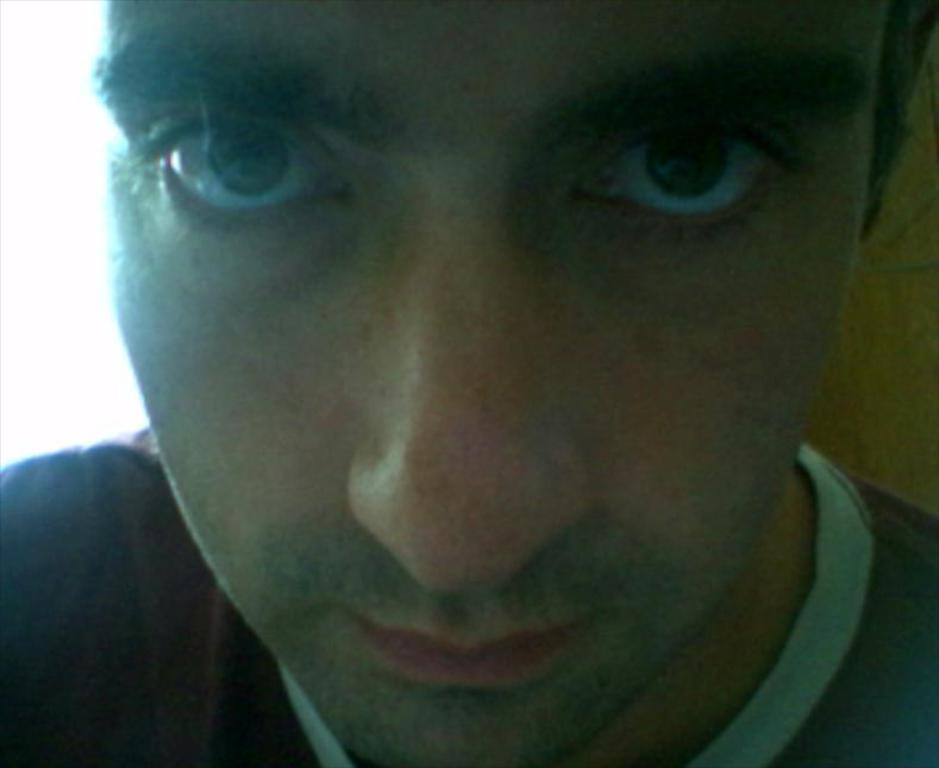Who is present in the image? There is a man in the image. What is the man wearing? The man is wearing a black T-shirt. What facial features are visible on the man? The man's eyes, nose, and mouth are visible. What is behind the man in the image? There is a wall behind the man. What color is the wall on the left side? The wall on the left side is white in color. Where is the girl holding the rake in the image? There is no girl or rake present in the image. What type of rabbit can be seen playing with the man in the image? There is no rabbit present in the image; only the man is visible. 